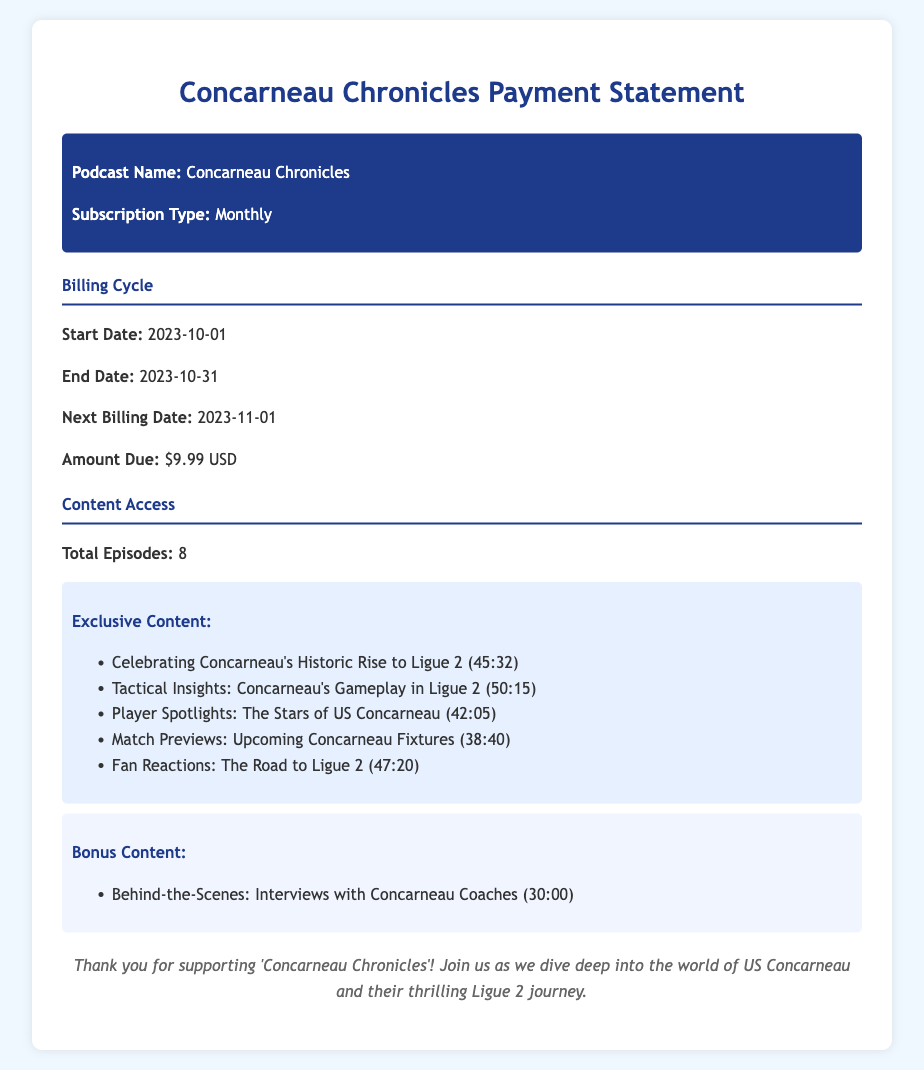what is the podcast name? The podcast name is specified in the document header.
Answer: Concarneau Chronicles what is the subscription type? The document states the subscription type in the header section.
Answer: Monthly what is the amount due? This figure is provided in the billing cycle section of the document.
Answer: $9.99 USD what is the start date of the billing cycle? The start date is clearly stated in the billing cycle section.
Answer: 2023-10-01 how many total episodes are there? The total number of episodes is mentioned in the content access section of the document.
Answer: 8 what is the next billing date? The next billing date is specified in the billing cycle section.
Answer: 2023-11-01 what is one of the exclusive content titles? The document lists exclusive content titles under the content access section.
Answer: Celebrating Concarneau's Historic Rise to Ligue 2 how long is the episode about Tactical Insights? The duration for the specific episode is provided in the exclusive content list.
Answer: 50:15 which bonus content is included? The document describes what bonus content is provided in the content access section.
Answer: Behind-the-Scenes: Interviews with Concarneau Coaches when does the billing cycle end? The end date is specified in the billing cycle section of the document.
Answer: 2023-10-31 